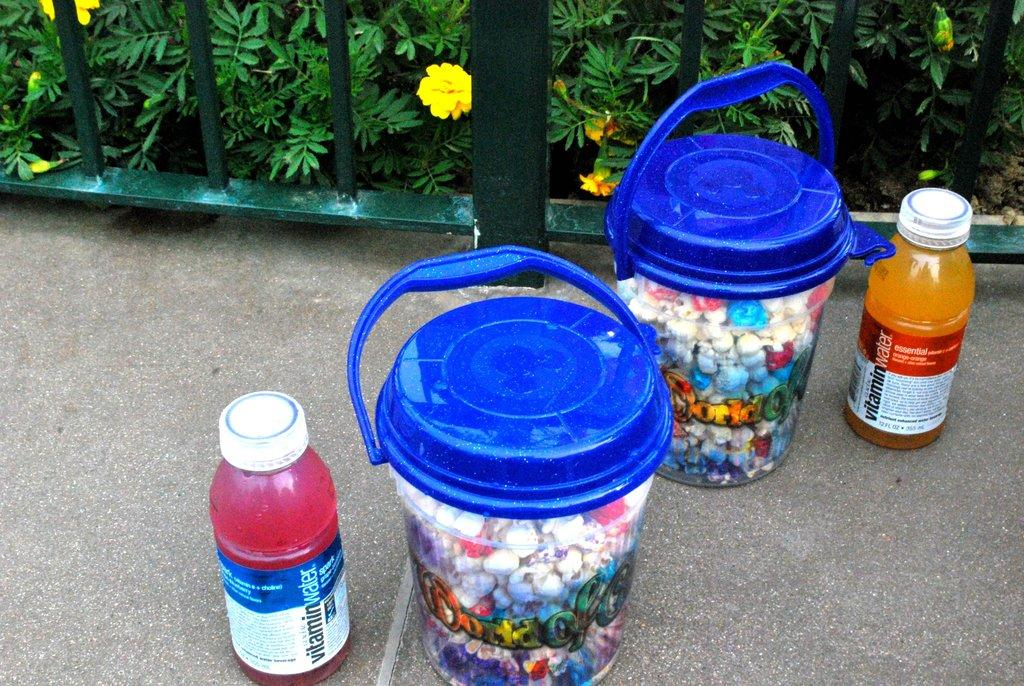Provide a one-sentence caption for the provided image. Two bottles of vitamin water next to two buckets. 